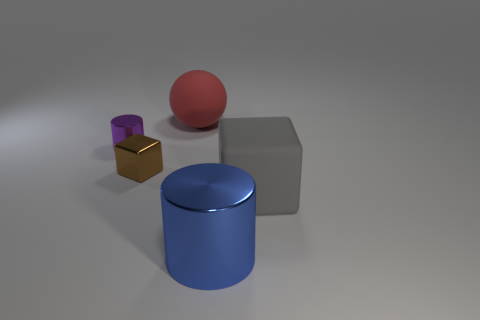Are there an equal number of balls that are in front of the tiny purple thing and small red metallic things?
Your answer should be very brief. Yes. There is a brown object; does it have the same size as the block that is in front of the metallic block?
Your response must be concise. No. What is the shape of the big matte object that is to the left of the big metal cylinder?
Keep it short and to the point. Sphere. Is there any other thing that has the same shape as the large red matte thing?
Provide a short and direct response. No. Are there any tiny blue matte blocks?
Ensure brevity in your answer.  No. There is a shiny cylinder that is in front of the small purple object; is it the same size as the rubber thing that is left of the gray matte object?
Ensure brevity in your answer.  Yes. What material is the thing that is behind the tiny brown metal block and in front of the matte sphere?
Give a very brief answer. Metal. What number of large spheres are behind the blue shiny object?
Your response must be concise. 1. What is the color of the big thing that is made of the same material as the tiny block?
Your answer should be very brief. Blue. Is the big gray object the same shape as the brown thing?
Your response must be concise. Yes. 